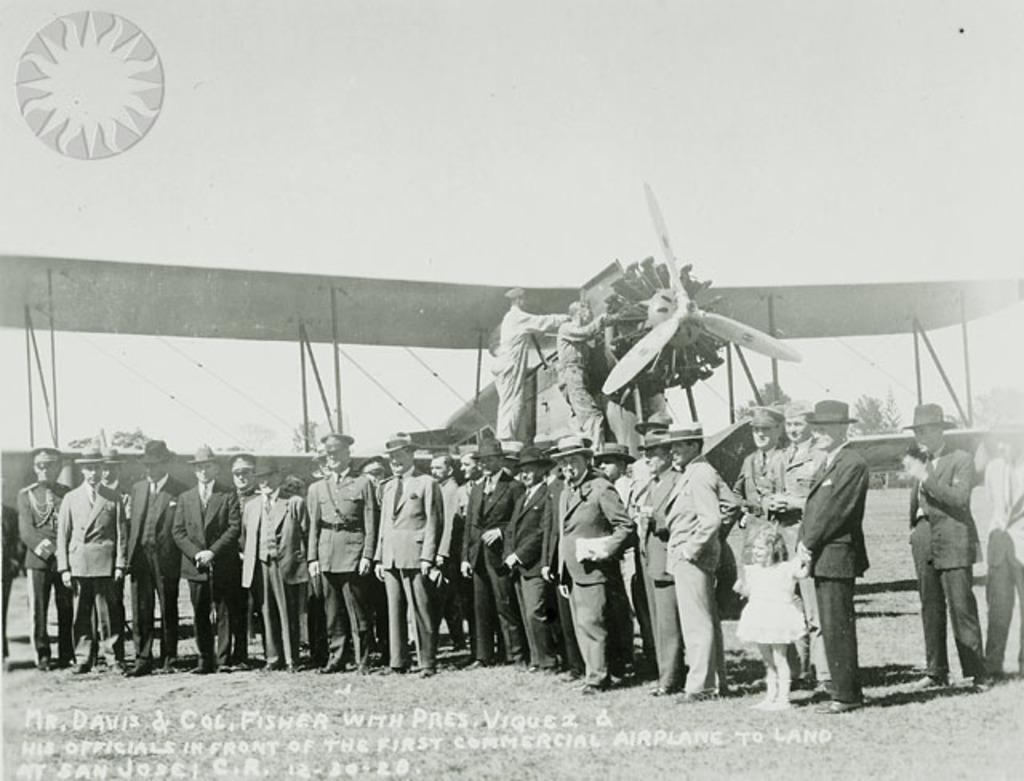<image>
Summarize the visual content of the image. The men are standing in front of the first commercial airplane to land at San Jose. 